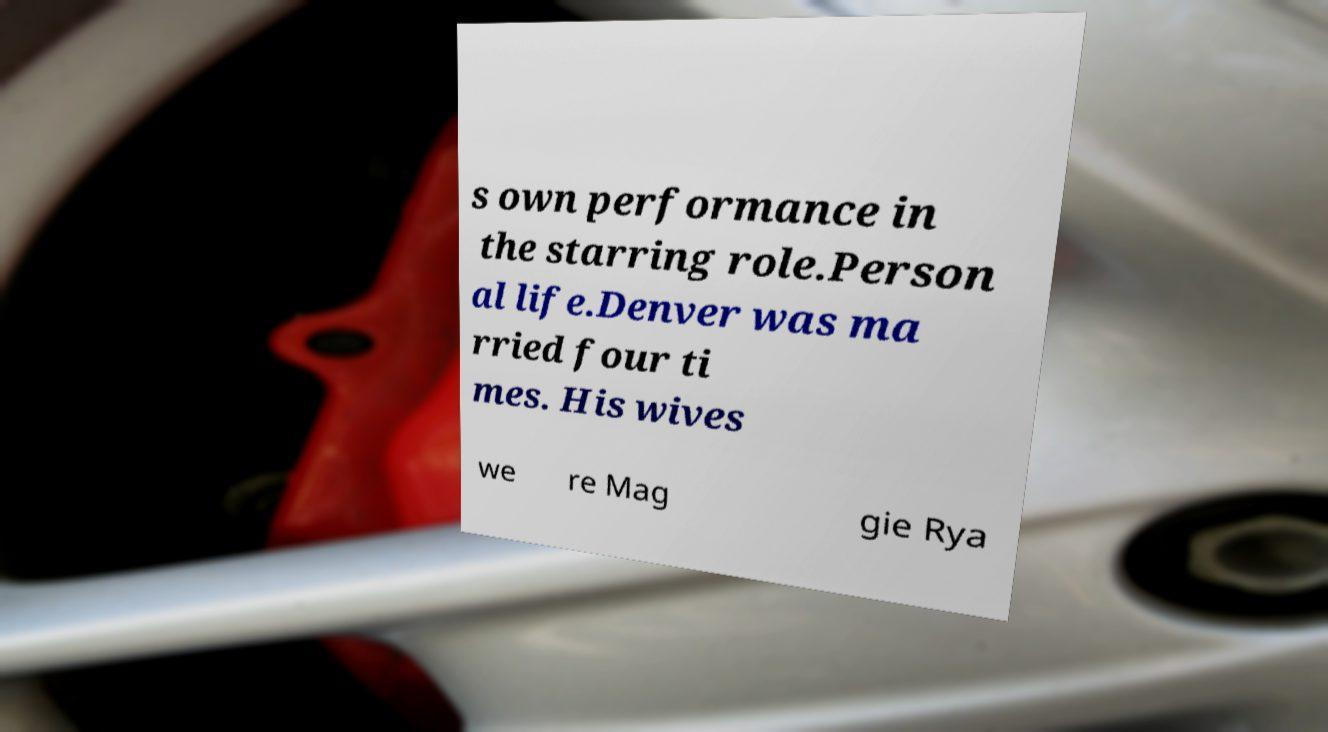Can you accurately transcribe the text from the provided image for me? s own performance in the starring role.Person al life.Denver was ma rried four ti mes. His wives we re Mag gie Rya 